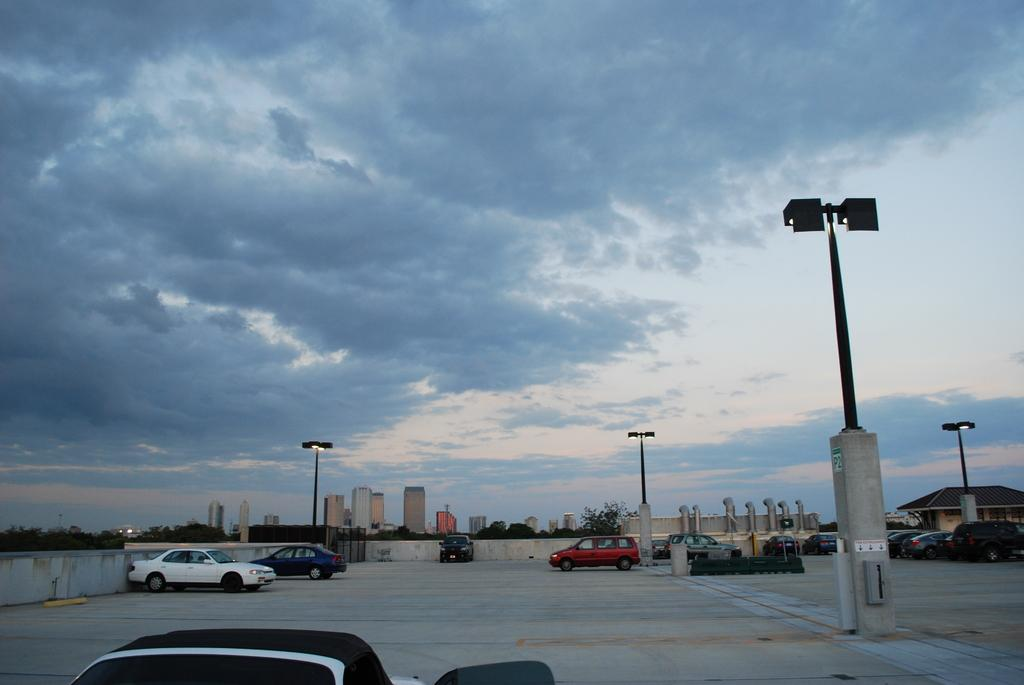What type of vehicles can be seen in the image? There are cars in the image. What structures are present in the image? There are light poles, buildings, and trees in the image. What is visible in the sky in the image? The sky is visible in the image, and it appears to be cloudy. Where is the stone used for cooking located in the image? There is no stone used for cooking present in the image. What type of fan can be seen in the image? There is no fan present in the image. 